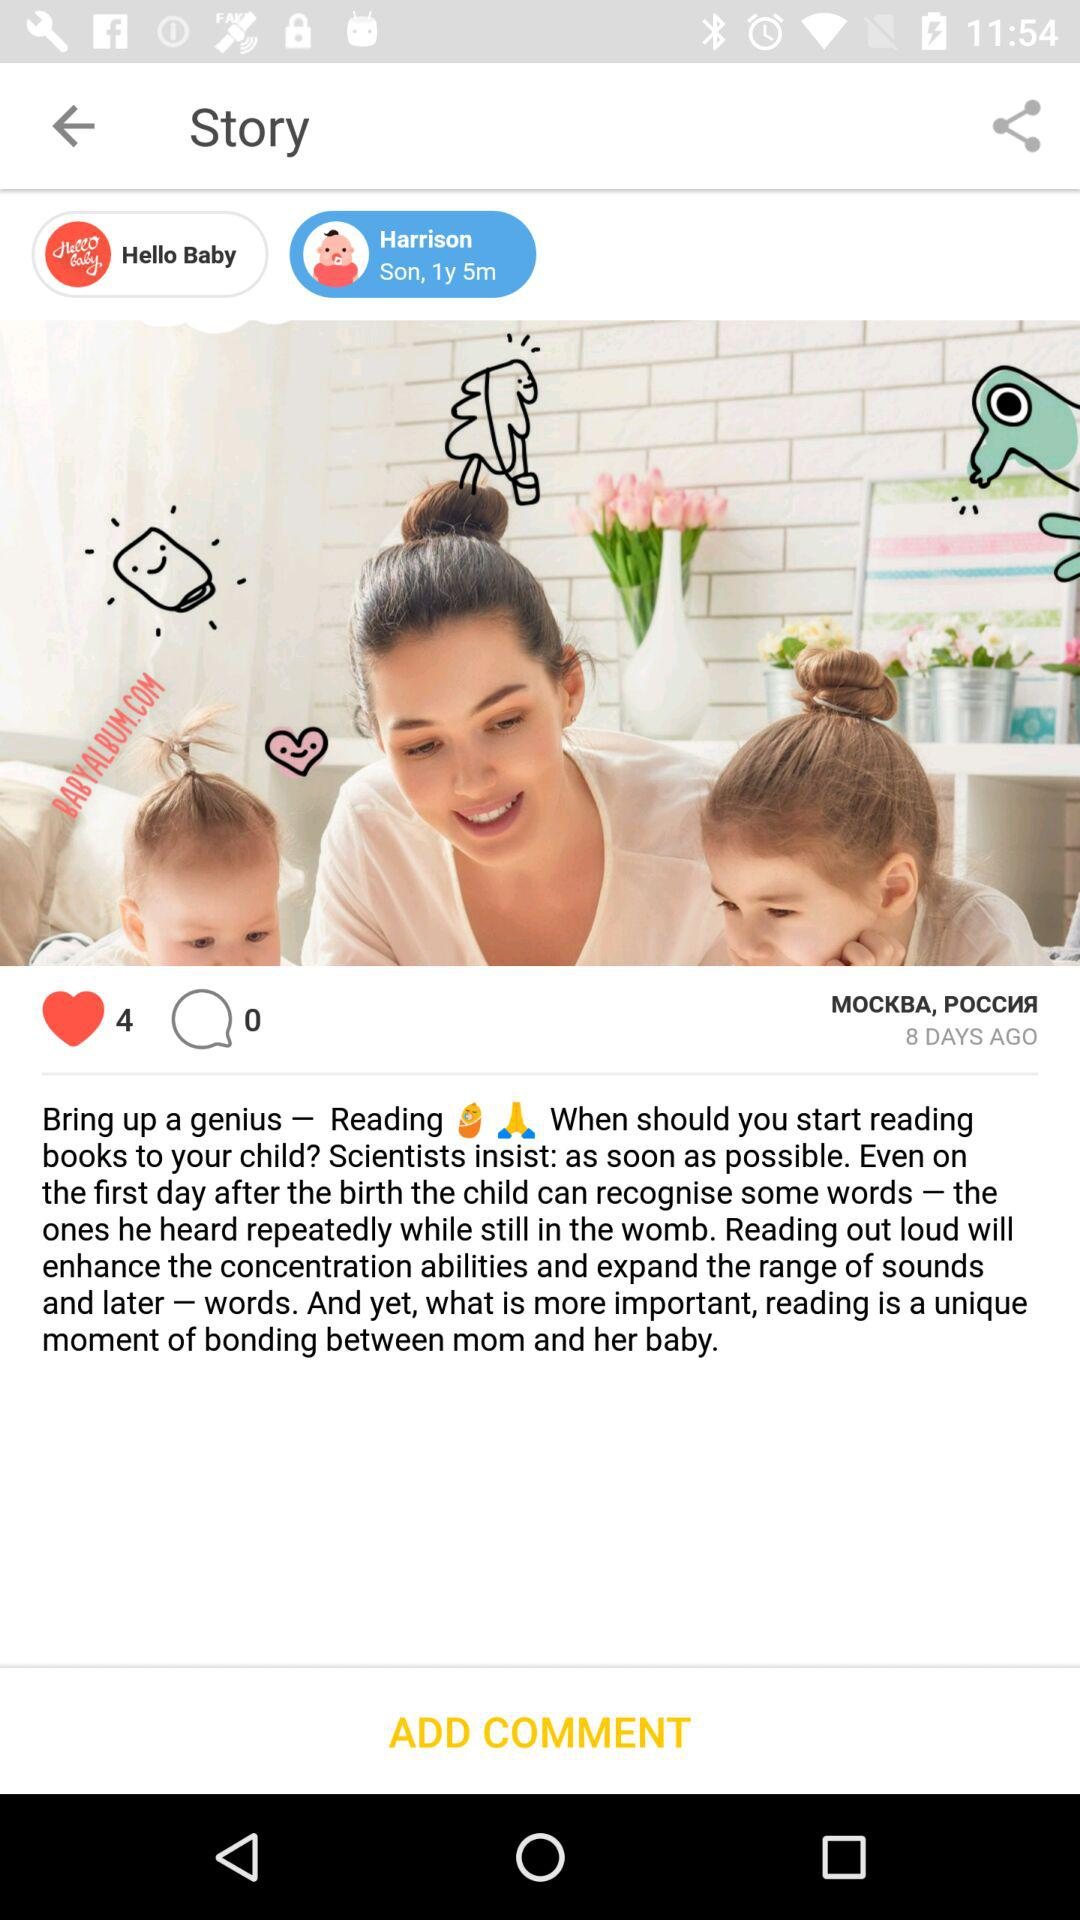What is the age of Harrison? Harrison's age is 1 year and 5 months. 